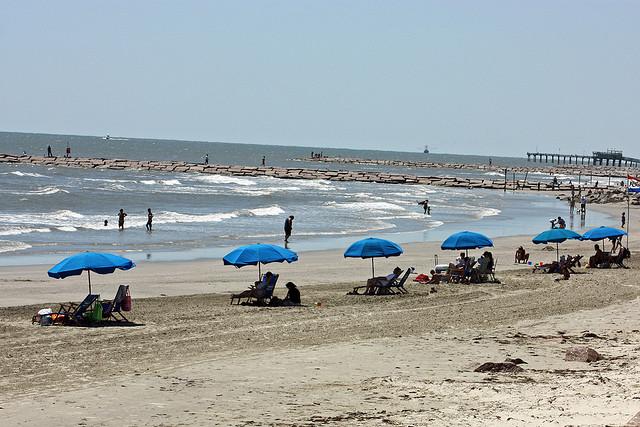Where are the people?
Write a very short answer. Beach. Is the beach mostly empty?
Give a very brief answer. Yes. What color are the umbrellas?
Give a very brief answer. Blue. How many blue umbrellas line the beach?
Be succinct. 6. 